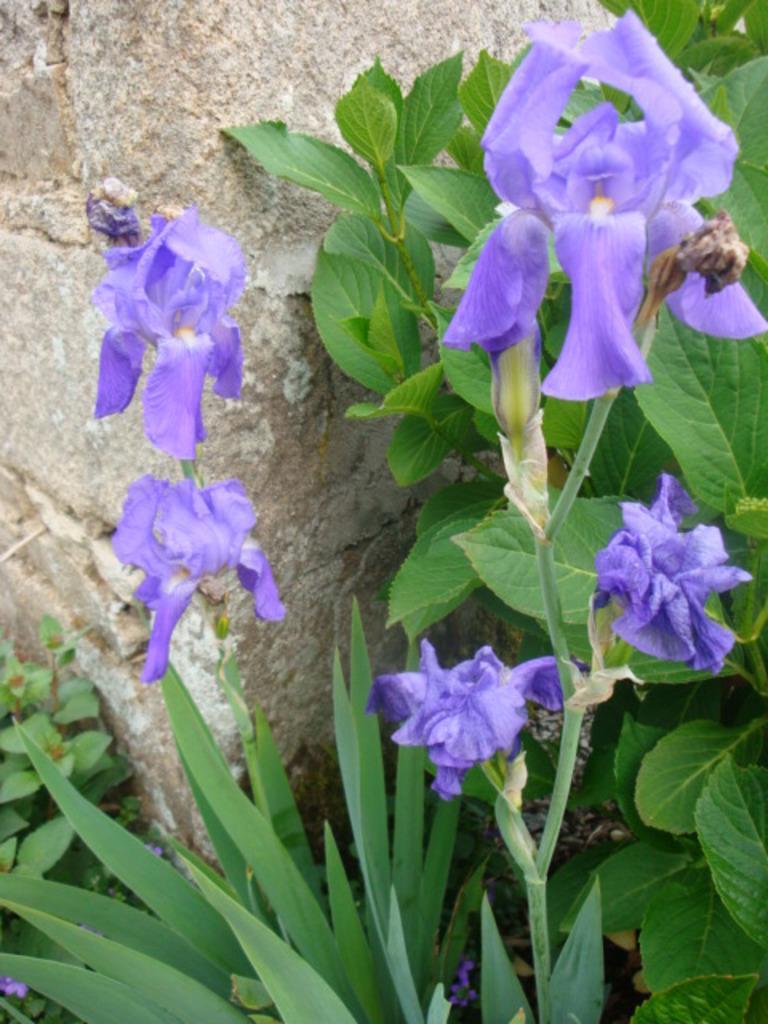In one or two sentences, can you explain what this image depicts? In this picture in the front there are flowers and there are leaves and in the background there is a wall. 